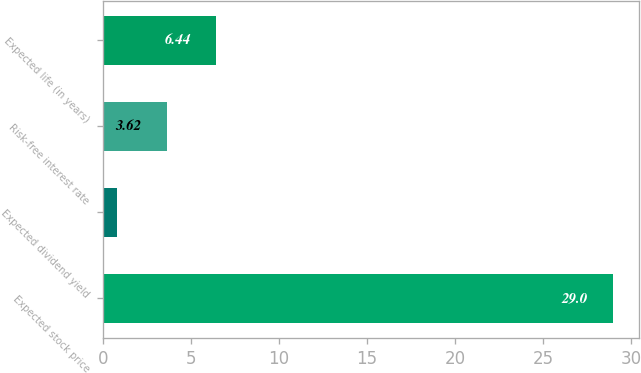Convert chart to OTSL. <chart><loc_0><loc_0><loc_500><loc_500><bar_chart><fcel>Expected stock price<fcel>Expected dividend yield<fcel>Risk-free interest rate<fcel>Expected life (in years)<nl><fcel>29<fcel>0.8<fcel>3.62<fcel>6.44<nl></chart> 